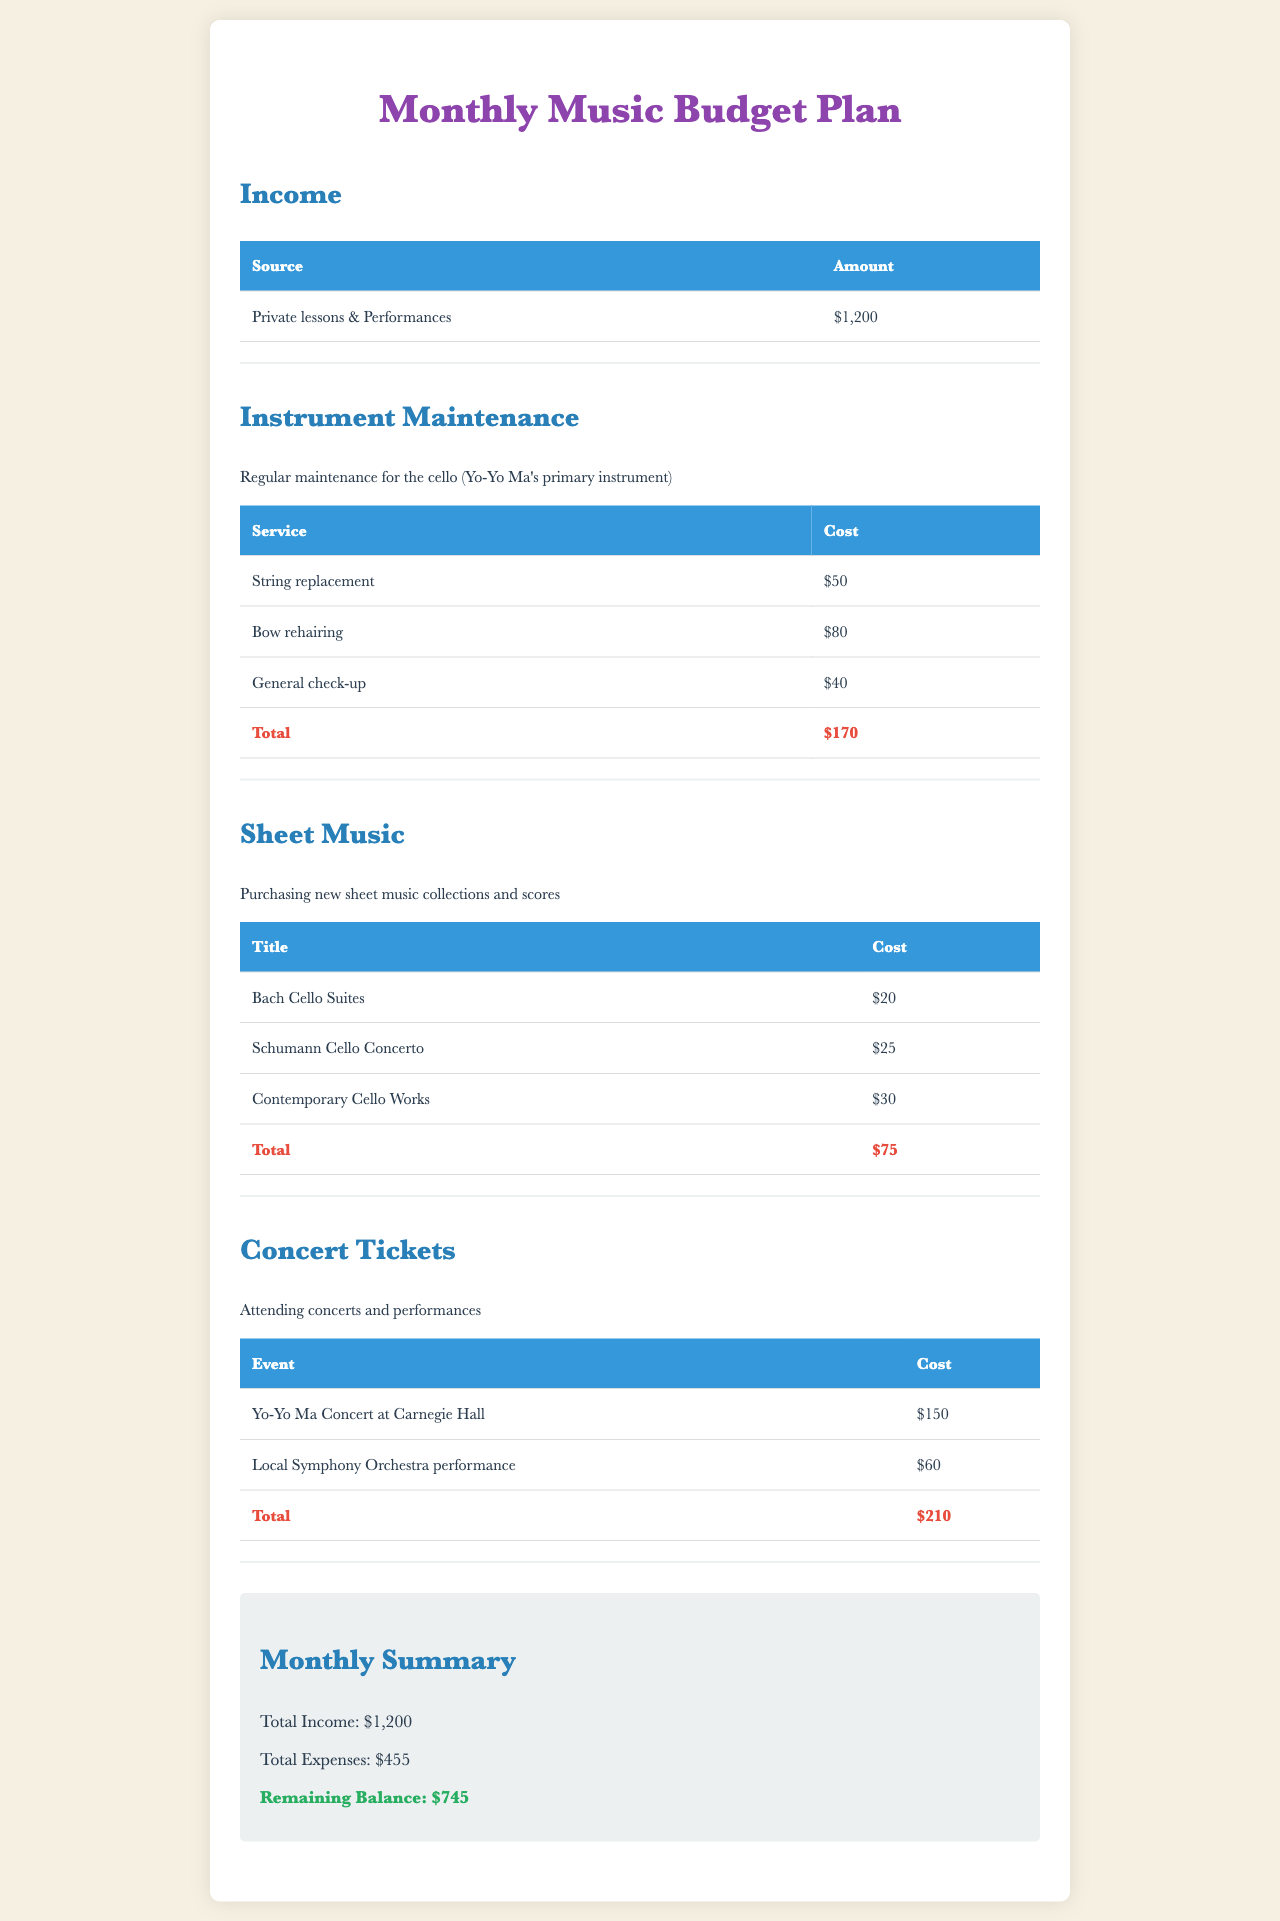what is the total income? The total income is listed in the summary section of the document as $1,200.
Answer: $1,200 what is the total cost for instrument maintenance? The total cost for instrument maintenance is shown in the table under that section, which totals $170.
Answer: $170 how much does the sheet music for Bach Cello Suites cost? The cost for the Bach Cello Suites is specified in the sheet music table as $20.
Answer: $20 what are the total concert ticket expenses? The total concert ticket expenses are summarized in that section, amounting to $210.
Answer: $210 which concert features Yo-Yo Ma? The concert featuring Yo-Yo Ma is titled "Yo-Yo Ma Concert at Carnegie Hall."
Answer: Yo-Yo Ma Concert at Carnegie Hall what is the remaining balance after expenses? The remaining balance is calculated as total income minus total expenses, reflected as $745 in the summary section.
Answer: $745 what is the cost for bow rehairing? The cost for bow rehairing is detailed in the instrument maintenance table as $80.
Answer: $80 how many pieces of sheet music were purchased? Three titles are listed in the sheet music section, indicating that three pieces were purchased.
Answer: Three what is the total cost for purchasing contemporary cello works? The total cost for contemporary cello works is noted as $30 in the sheet music table.
Answer: $30 what is the total expenses reported in the document? The total expenses are summed up in the summary section as $455.
Answer: $455 